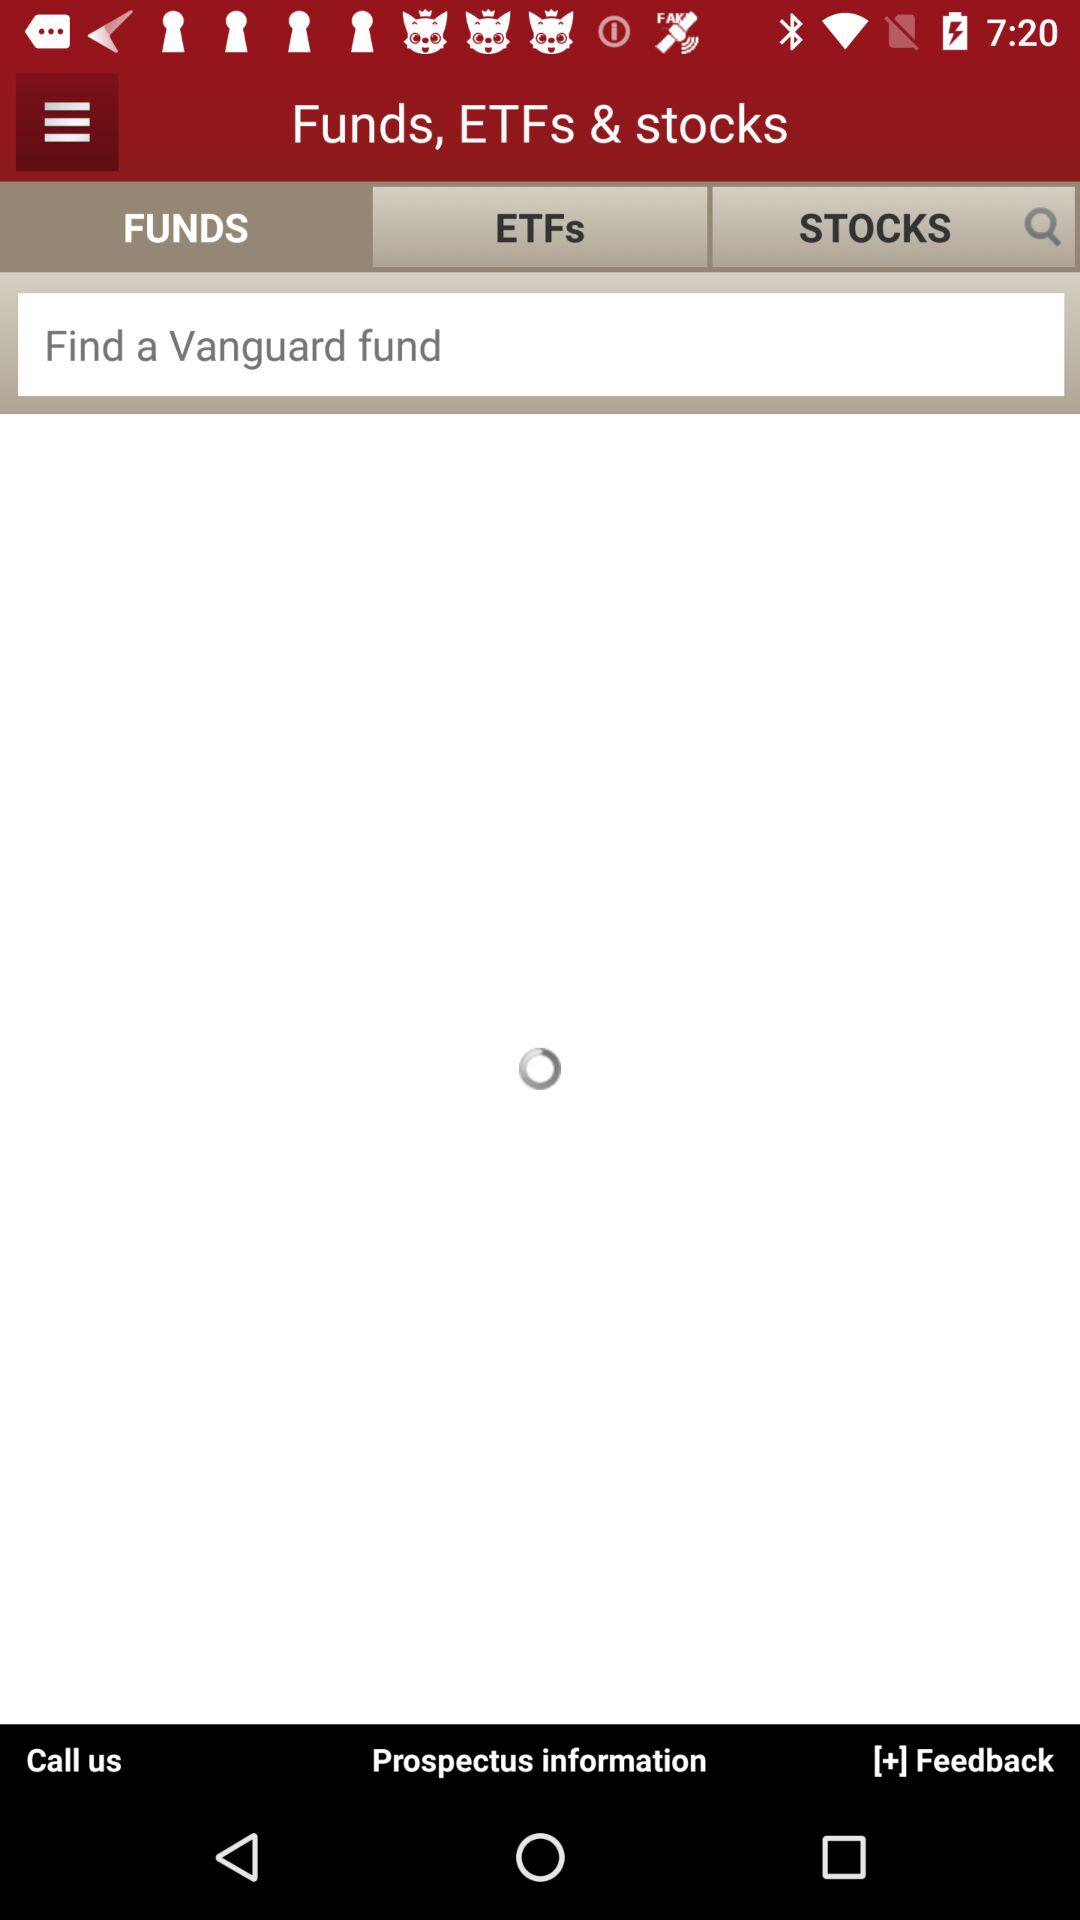How many stocks are there?
When the provided information is insufficient, respond with <no answer>. <no answer> 